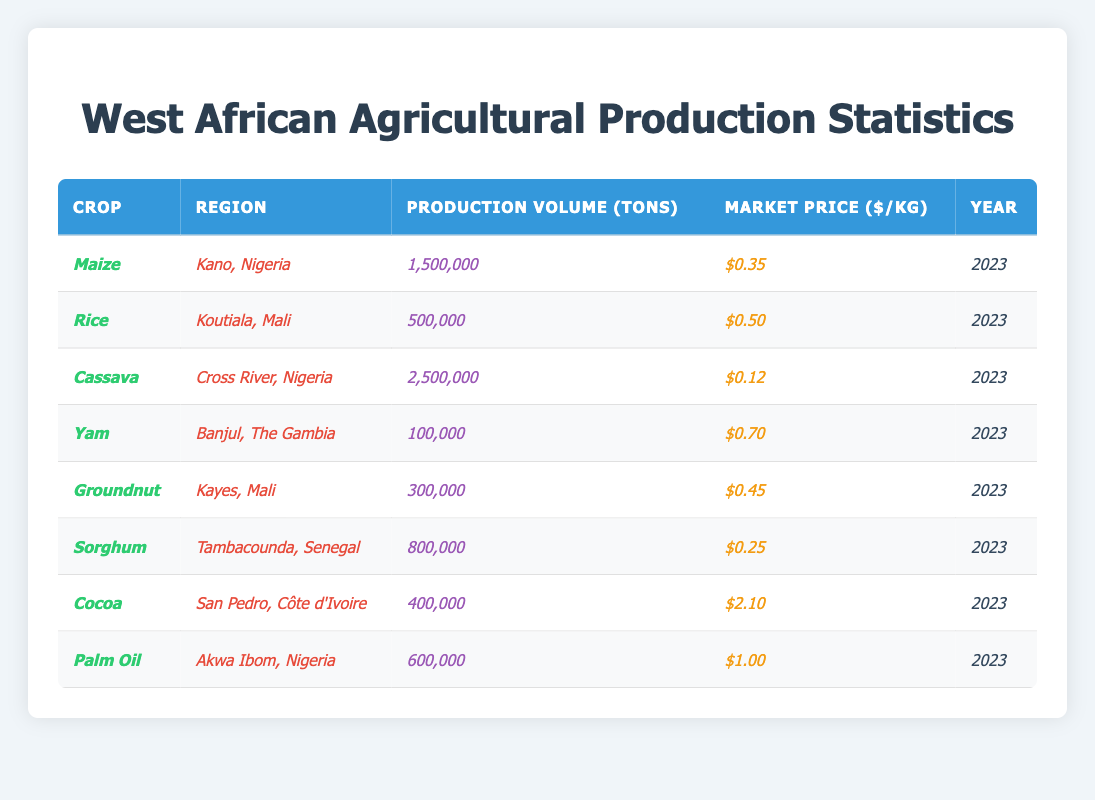What is the market price per kg of Cassava? The table shows the market price of Cassava in Cross River, Nigeria is listed under the column "Market Price ($/kg)", which is $0.12.
Answer: $0.12 Which crop has the highest production volume in tons? By reviewing the "Production Volume (tons)" column, Cassava has the highest production volume at 2,500,000 tons.
Answer: Cassava Is the market price of Yam higher than that of Sorghum? The market price for Yam is $0.70, while for Sorghum it is $0.25. Since $0.70 is greater than $0.25, the statement is true.
Answer: Yes How many tons of Groundnut were produced in Kayes, Mali? In the table, Groundnut's production volume in Kayes, Mali is listed as 300,000 tons under the "Production Volume (tons)" column.
Answer: 300,000 tons What is the total production volume of Maize and Rice combined? The production volume of Maize is 1,500,000 tons and Rice is 500,000 tons. Adding these together gives 1,500,000 + 500,000 = 2,000,000 tons.
Answer: 2,000,000 tons Which crop has the lowest market price per kg? The table indicates that Cassava has the lowest market price listed at $0.12 per kg, lower than any other crop listed.
Answer: Cassava What region produces the highest volume of Palm Oil? The table lists Palm Oil production in Akwa Ibom, Nigeria, with a production volume of 600,000 tons. The question is specific to the region producing Palm Oil, which is Akwa Ibom.
Answer: Akwa Ibom, Nigeria If the average market price for all the crops is calculated, what is it? First, sum the market prices: $0.35 + $0.50 + $0.12 + $0.70 + $0.45 + $0.25 + $2.10 + $1.00 = $5.47. There are 8 crops, so the average price is $5.47 / 8 = $0.68375, which can be rounded to $0.68.
Answer: $0.68 Is the total production volume of Cocoa greater than that of Groundnut? Cocoa has a production volume of 400,000 tons and Groundnut has 300,000 tons. Since 400,000 is greater than 300,000, the statement is true.
Answer: Yes What is the production volume difference between Sorghum and Yam? Sorghum's production volume is 800,000 tons, and Yam's is 100,000 tons. The difference is 800,000 - 100,000 = 700,000 tons.
Answer: 700,000 tons 